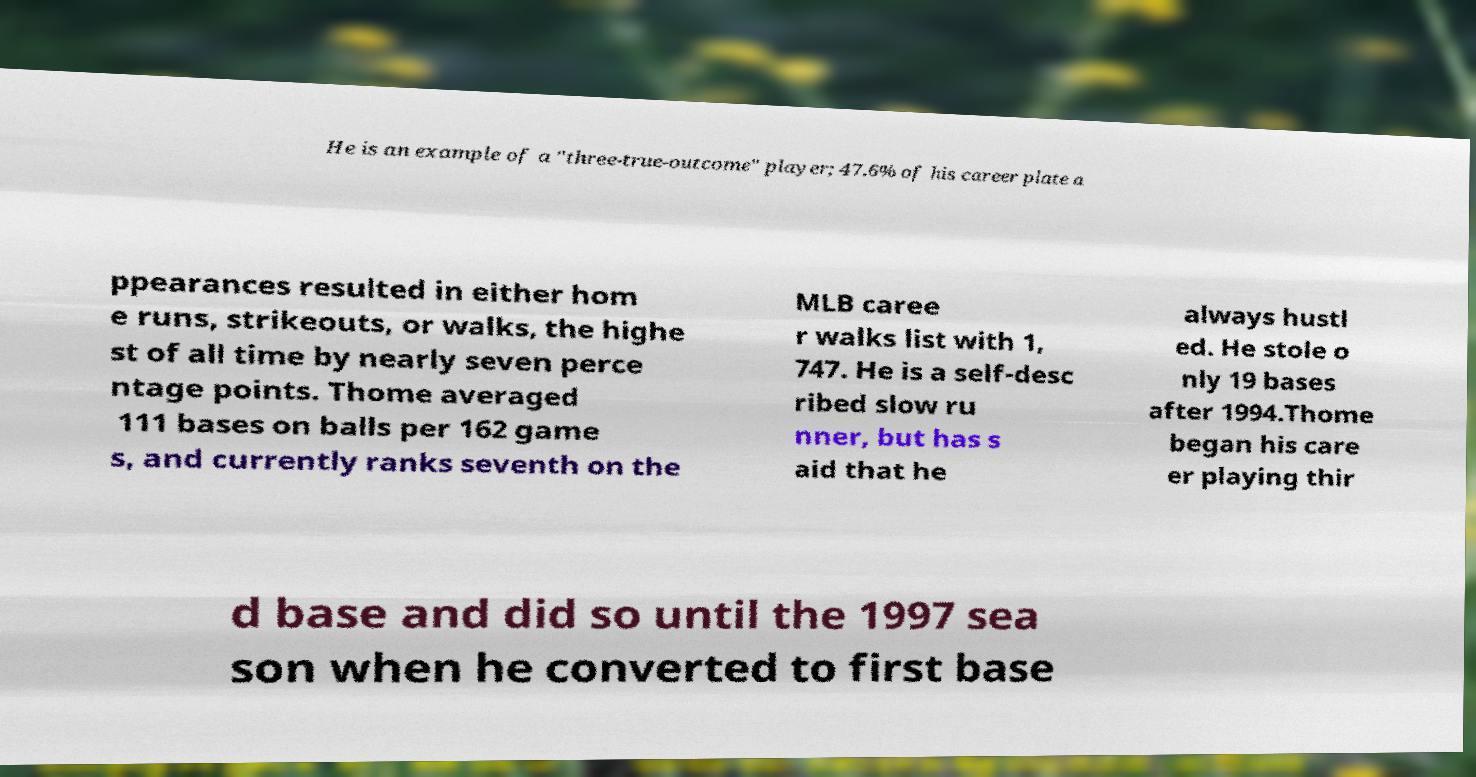What messages or text are displayed in this image? I need them in a readable, typed format. He is an example of a "three-true-outcome" player; 47.6% of his career plate a ppearances resulted in either hom e runs, strikeouts, or walks, the highe st of all time by nearly seven perce ntage points. Thome averaged 111 bases on balls per 162 game s, and currently ranks seventh on the MLB caree r walks list with 1, 747. He is a self-desc ribed slow ru nner, but has s aid that he always hustl ed. He stole o nly 19 bases after 1994.Thome began his care er playing thir d base and did so until the 1997 sea son when he converted to first base 